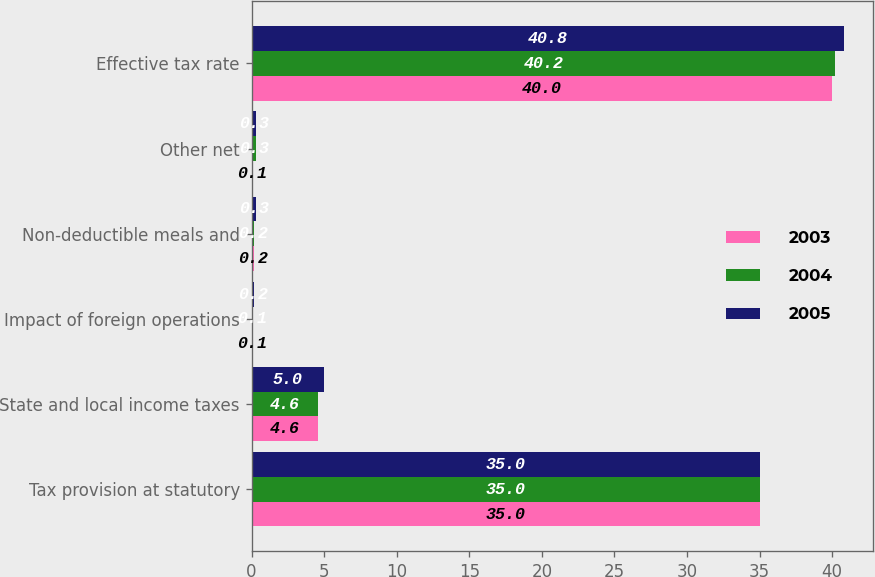<chart> <loc_0><loc_0><loc_500><loc_500><stacked_bar_chart><ecel><fcel>Tax provision at statutory<fcel>State and local income taxes<fcel>Impact of foreign operations<fcel>Non-deductible meals and<fcel>Other net<fcel>Effective tax rate<nl><fcel>2003<fcel>35<fcel>4.6<fcel>0.1<fcel>0.2<fcel>0.1<fcel>40<nl><fcel>2004<fcel>35<fcel>4.6<fcel>0.1<fcel>0.2<fcel>0.3<fcel>40.2<nl><fcel>2005<fcel>35<fcel>5<fcel>0.2<fcel>0.3<fcel>0.3<fcel>40.8<nl></chart> 